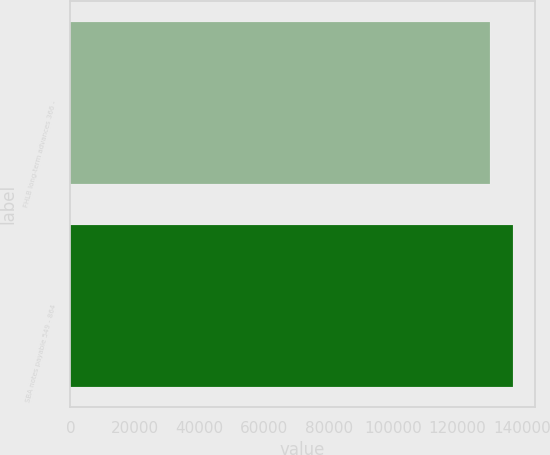Convert chart. <chart><loc_0><loc_0><loc_500><loc_500><bar_chart><fcel>FHLB long-term advances 366 -<fcel>SBA notes payable 549 - 864<nl><fcel>130058<fcel>137058<nl></chart> 